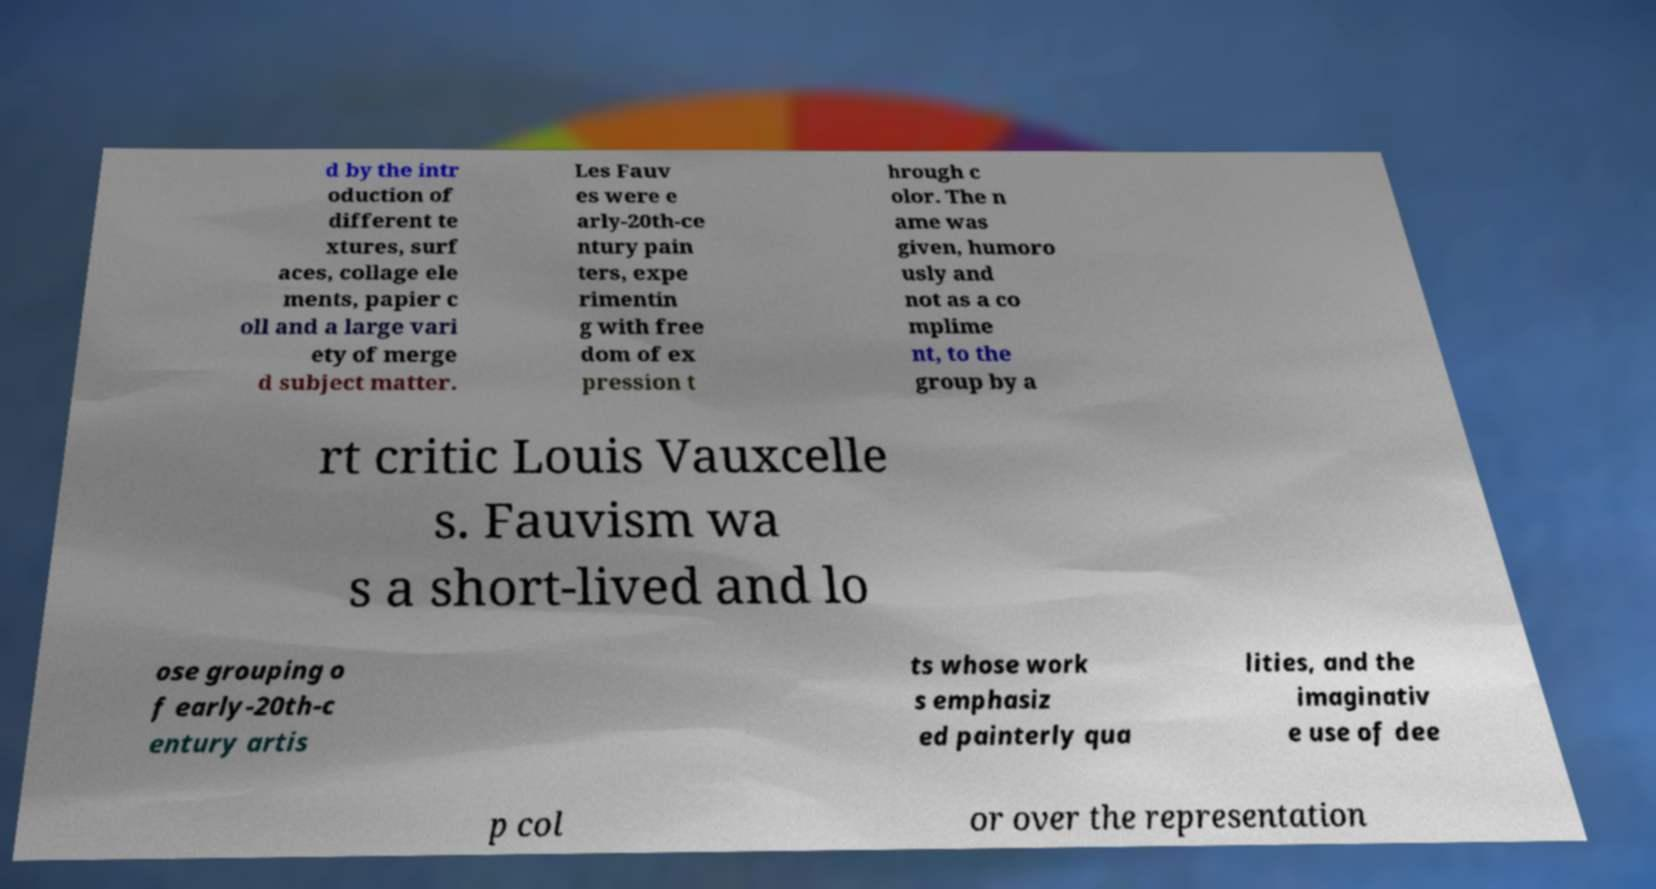For documentation purposes, I need the text within this image transcribed. Could you provide that? d by the intr oduction of different te xtures, surf aces, collage ele ments, papier c oll and a large vari ety of merge d subject matter. Les Fauv es were e arly-20th-ce ntury pain ters, expe rimentin g with free dom of ex pression t hrough c olor. The n ame was given, humoro usly and not as a co mplime nt, to the group by a rt critic Louis Vauxcelle s. Fauvism wa s a short-lived and lo ose grouping o f early-20th-c entury artis ts whose work s emphasiz ed painterly qua lities, and the imaginativ e use of dee p col or over the representation 